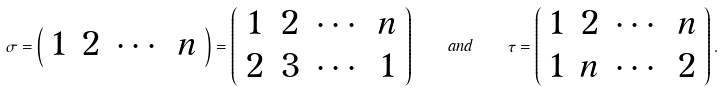<formula> <loc_0><loc_0><loc_500><loc_500>\sigma = \left ( \begin{array} { c c c c } 1 & 2 & \cdots & n \end{array} \right ) = \left ( \begin{array} { c c c c } 1 & 2 & \cdots & n \\ 2 & 3 & \cdots & 1 \end{array} \right ) \quad a n d \quad \tau = \left ( \begin{array} { c c c c } 1 & 2 & \cdots & n \\ 1 & n & \cdots & 2 \end{array} \right ) .</formula> 